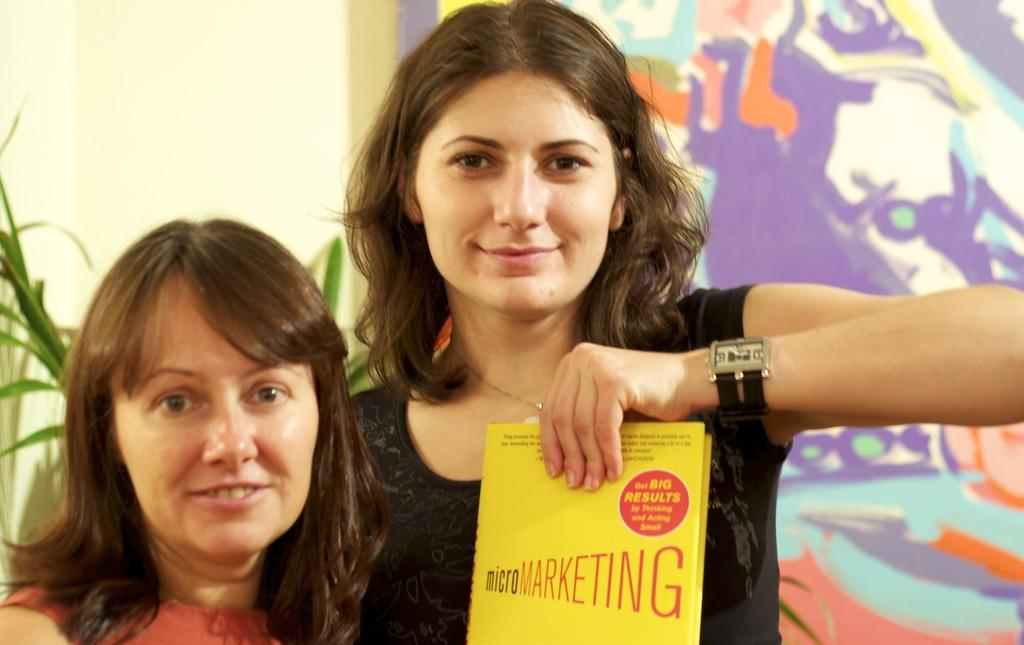How many women are in the image? There are two women in the image. What is one of the women holding? One woman is holding a book. What can be found inside the book? The book contains text. What type of vegetation is visible in the image? There is a plant visible in the image. What is hanging on the wall in the image? There is a painting hanging on the wall in the image. What type of drum is being played by one of the women in the image? There is no drum present in the image; both women are focused on the book and plant. 